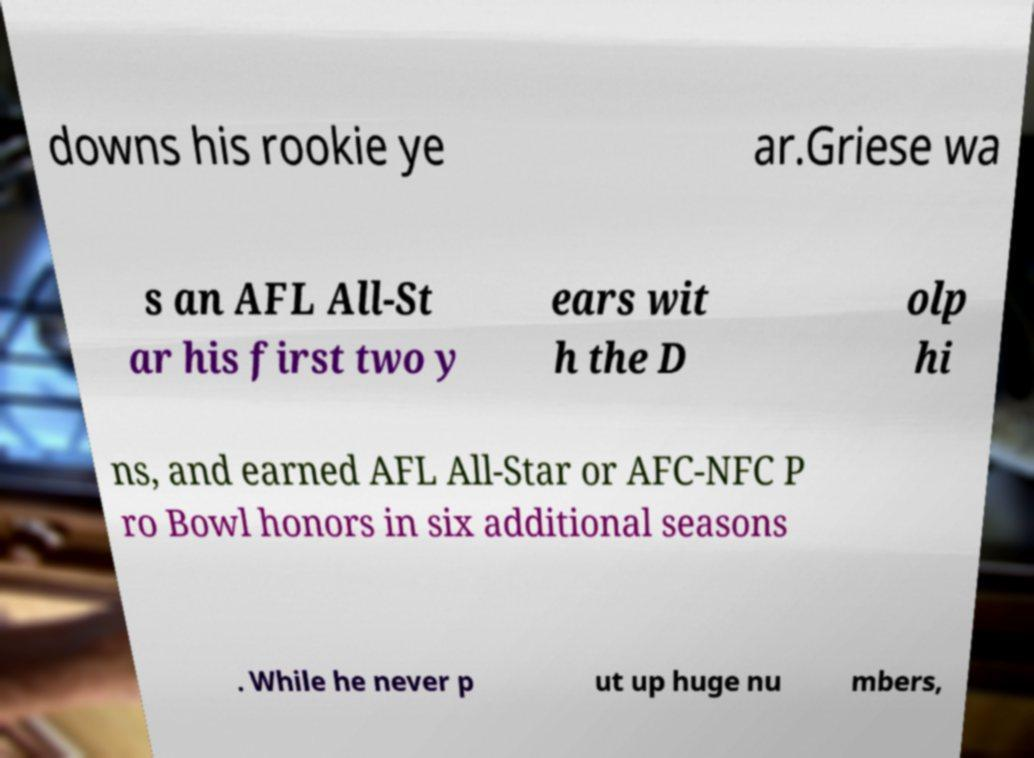What messages or text are displayed in this image? I need them in a readable, typed format. downs his rookie ye ar.Griese wa s an AFL All-St ar his first two y ears wit h the D olp hi ns, and earned AFL All-Star or AFC-NFC P ro Bowl honors in six additional seasons . While he never p ut up huge nu mbers, 